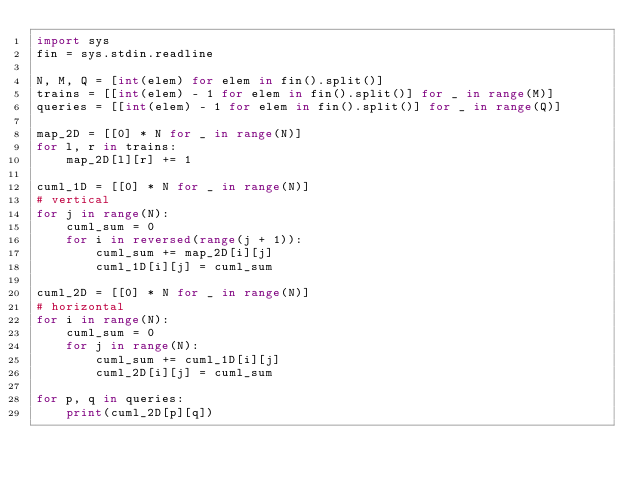Convert code to text. <code><loc_0><loc_0><loc_500><loc_500><_Python_>import sys 
fin = sys.stdin.readline

N, M, Q = [int(elem) for elem in fin().split()]
trains = [[int(elem) - 1 for elem in fin().split()] for _ in range(M)]
queries = [[int(elem) - 1 for elem in fin().split()] for _ in range(Q)]

map_2D = [[0] * N for _ in range(N)]
for l, r in trains:
    map_2D[l][r] += 1

cuml_1D = [[0] * N for _ in range(N)]
# vertical
for j in range(N):
    cuml_sum = 0
    for i in reversed(range(j + 1)):
        cuml_sum += map_2D[i][j]
        cuml_1D[i][j] = cuml_sum

cuml_2D = [[0] * N for _ in range(N)]
# horizontal
for i in range(N):
    cuml_sum = 0
    for j in range(N):
        cuml_sum += cuml_1D[i][j]
        cuml_2D[i][j] = cuml_sum

for p, q in queries:
    print(cuml_2D[p][q])
</code> 